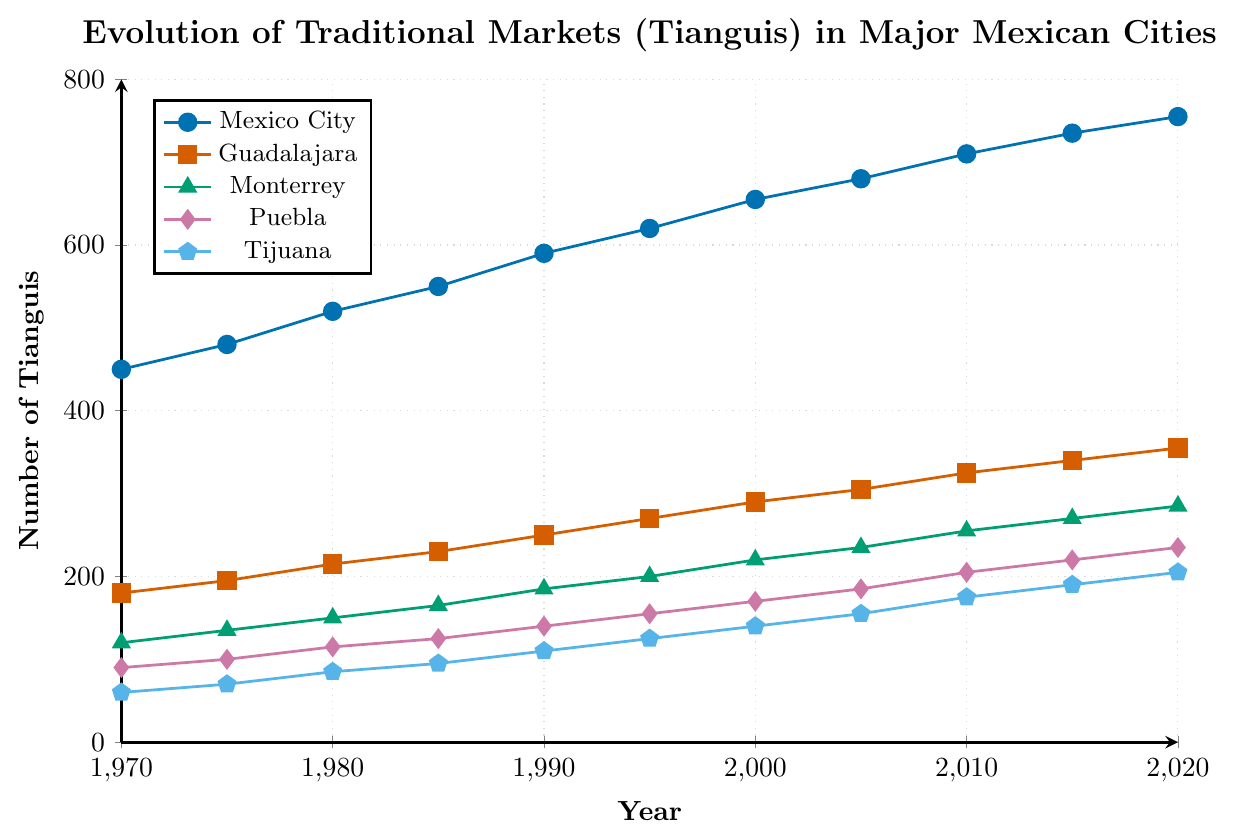What's the overall trend in the number of tianguis in Mexico City from 1970 to 2020? The number of tianguis in Mexico City increases steadily from 450 in 1970 to 755 in 2020. By visual inspection, we see a consistent upward trajectory throughout the years.
Answer: Upward trend Which city had the fewest tianguis in 2020? In 2020, visually comparing the endpoints of the lines representing each city, the line for Tijuana is the lowest, indicating the fewest tianguis among the cities at 205.
Answer: Tijuana By how much did the number of tianguis in Puebla change from 1990 to 2020? In 1990, Puebla had 140 tianguis and in 2020, it had 235. The change is calculated as 235 - 140 = 95.
Answer: 95 Compare the growth rate of tianguis in Guadalajara and Monterrey between 1970 and 2020. For Guadalajara, the increase from 1970 (180) to 2020 (355) is 355 - 180 = 175. For Monterrey, the increase is from 120 in 1970 to 285 in 2020, so 285 - 120 = 165. Comparing the two, Guadalajara had a higher increase by 10 tianguis.
Answer: Guadalajara had a higher increase Which city shows the smallest increase in the number of tianguis from 1970 to 2020? By examining the initial and final values for each city, Tijuana grew from 60 in 1970 to 205 in 2020, showing an increase of 145. This is the smallest increase among the listed cities.
Answer: Tijuana What is the average number of tianguis in Monterrey over the past 50 years? The values for Monterrey are 120, 135, 150, 165, 185, 200, 220, 235, 255, 270, 285. Summing these gives 2320, and the average is 2320 / 11 = 210.91.
Answer: 210.91 How does the number of tianguis in Mexico City in 1980 compare to Puebla in 2020? In 1980, Mexico City had 520 tianguis, and by 2020 Puebla had 235, so Mexico City had more tianguis in 1980.
Answer: Mexico City had more Between which years did Guadalajara see the highest increase in tianguis? To determine the highest increase, examine the differences between sequential years: (195 - 180 = 15, 215 - 195 = 20, 230 - 215 = 15, 250 - 230 = 20, 270 - 250 = 20, 290 - 270 = 20, 305 - 290 = 15, 325 - 305 = 20, 340 - 325 = 15, 355 - 340 = 15). The highest increase of 20 tianguis occurred between 1980-1985, 1990-1995, 2000-2005, and 2005-2010.
Answer: 1980-1985 Which two cities had the closest number of tianguis in 1990? In 1990, the numbers are Mexico City (590), Guadalajara (250), Monterrey (185), Puebla (140), and Tijuana (110). The closest pair is Puebla and Tijuana with a difference of 30 (140 - 110).
Answer: Puebla and Tijuana 